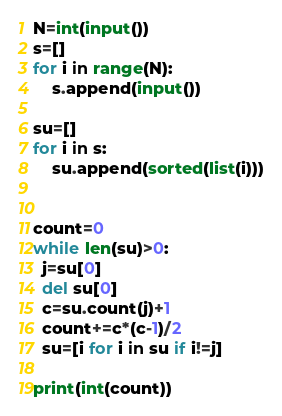<code> <loc_0><loc_0><loc_500><loc_500><_Python_>N=int(input())
s=[]
for i in range(N):
    s.append(input())

su=[]
for i in s:
    su.append(sorted(list(i)))


count=0
while len(su)>0:
  j=su[0]
  del su[0]
  c=su.count(j)+1
  count+=c*(c-1)/2
  su=[i for i in su if i!=j]
  
print(int(count))</code> 